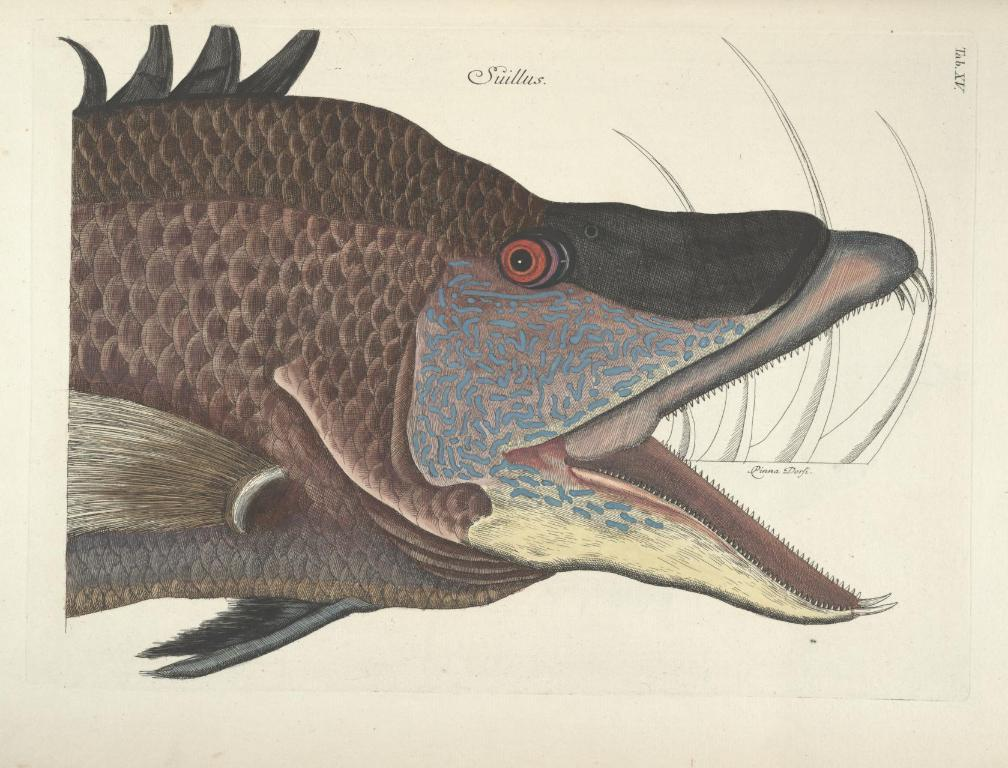What is depicted in the drawing in the image? There is a drawing of a fish in the image. What else can be seen on the paper in the image? There is text on the paper in the image. How does the tiger turn the clock in the image? There is no tiger or clock present in the image; it only features a drawing of a fish and text on a paper. 